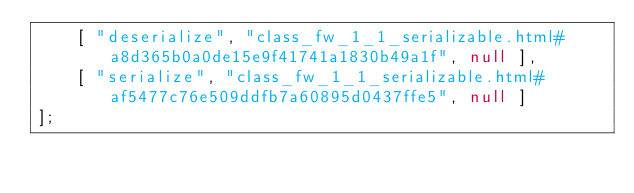Convert code to text. <code><loc_0><loc_0><loc_500><loc_500><_JavaScript_>    [ "deserialize", "class_fw_1_1_serializable.html#a8d365b0a0de15e9f41741a1830b49a1f", null ],
    [ "serialize", "class_fw_1_1_serializable.html#af5477c76e509ddfb7a60895d0437ffe5", null ]
];</code> 